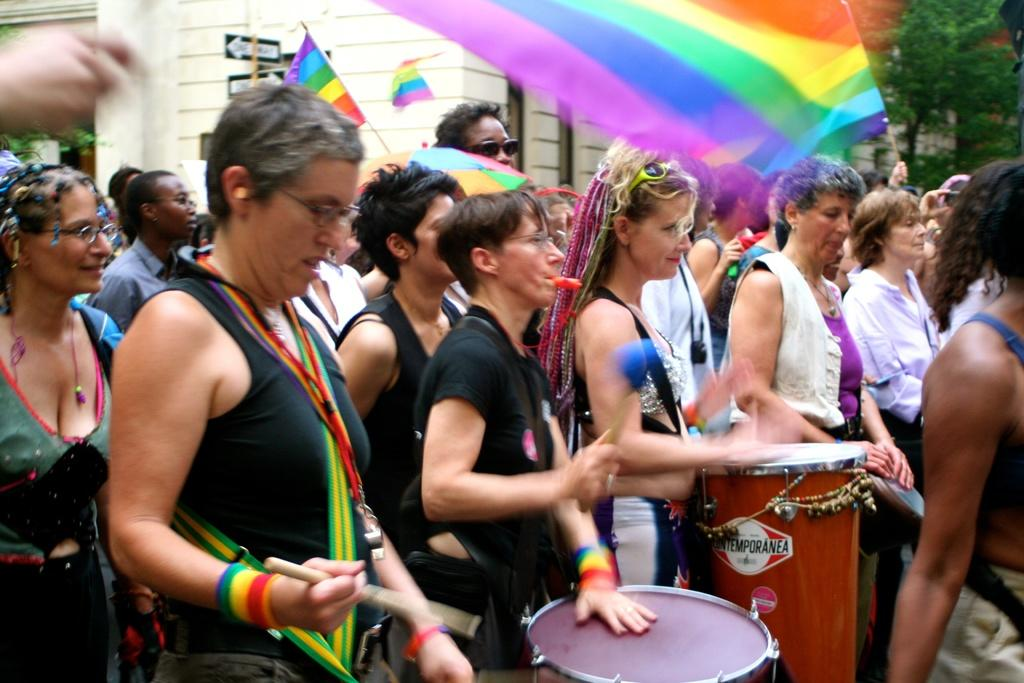What is happening in the image involving a group of people? In the image, there is a group of people, some of whom are playing drums and holding flags. What are the people playing drums using? The people playing drums are using drumsticks or their hands to play the drums. What are the flags made of? The flags are made of fabric or a similar material. How many water sources are visible in the image? There are no water sources visible in the image. What type of mitten is being used by the people holding flags? There are no mittens present in the image. 